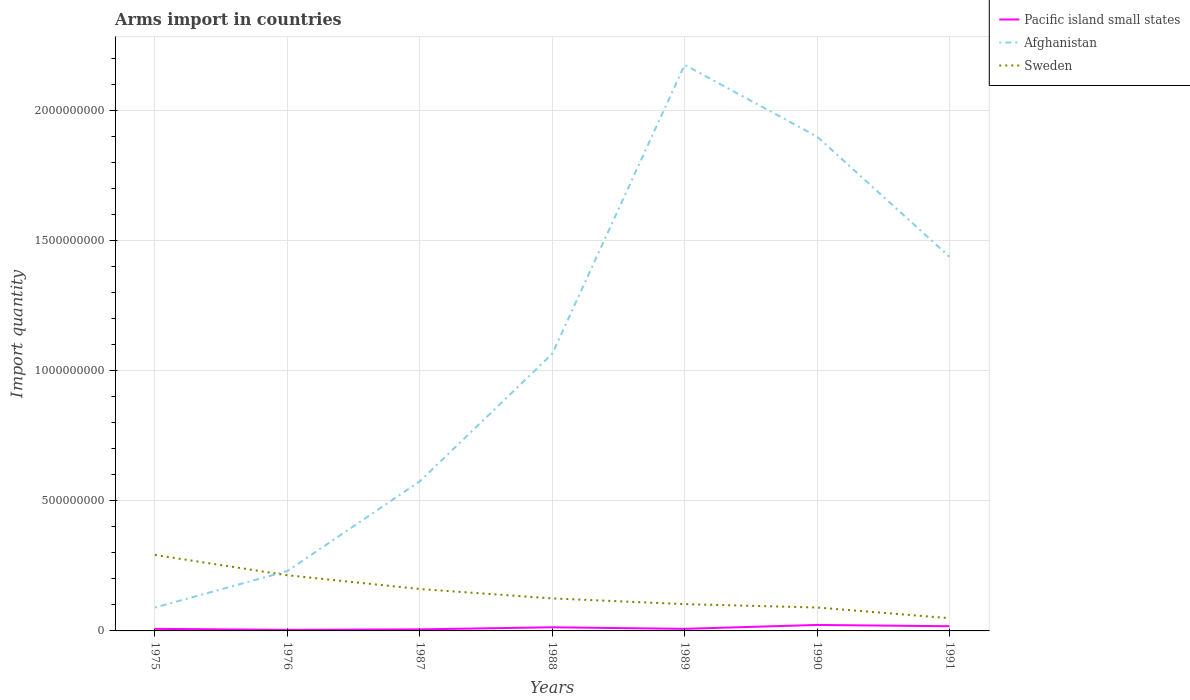Across all years, what is the maximum total arms import in Pacific island small states?
Provide a short and direct response. 4.00e+06. In which year was the total arms import in Pacific island small states maximum?
Offer a terse response. 1976. What is the total total arms import in Sweden in the graph?
Keep it short and to the point. 7.10e+07. What is the difference between the highest and the second highest total arms import in Afghanistan?
Make the answer very short. 2.09e+09. What is the difference between the highest and the lowest total arms import in Afghanistan?
Your answer should be compact. 3. Is the total arms import in Sweden strictly greater than the total arms import in Pacific island small states over the years?
Make the answer very short. No. How many lines are there?
Give a very brief answer. 3. How many years are there in the graph?
Keep it short and to the point. 7. Where does the legend appear in the graph?
Keep it short and to the point. Top right. How many legend labels are there?
Offer a terse response. 3. How are the legend labels stacked?
Give a very brief answer. Vertical. What is the title of the graph?
Your response must be concise. Arms import in countries. What is the label or title of the Y-axis?
Offer a terse response. Import quantity. What is the Import quantity of Pacific island small states in 1975?
Your answer should be very brief. 8.00e+06. What is the Import quantity of Afghanistan in 1975?
Give a very brief answer. 9.00e+07. What is the Import quantity of Sweden in 1975?
Your response must be concise. 2.92e+08. What is the Import quantity of Afghanistan in 1976?
Provide a short and direct response. 2.30e+08. What is the Import quantity of Sweden in 1976?
Keep it short and to the point. 2.14e+08. What is the Import quantity of Afghanistan in 1987?
Your answer should be very brief. 5.75e+08. What is the Import quantity in Sweden in 1987?
Your response must be concise. 1.61e+08. What is the Import quantity in Pacific island small states in 1988?
Offer a very short reply. 1.40e+07. What is the Import quantity in Afghanistan in 1988?
Your answer should be compact. 1.06e+09. What is the Import quantity of Sweden in 1988?
Provide a succinct answer. 1.25e+08. What is the Import quantity of Pacific island small states in 1989?
Keep it short and to the point. 8.00e+06. What is the Import quantity in Afghanistan in 1989?
Provide a short and direct response. 2.18e+09. What is the Import quantity of Sweden in 1989?
Provide a short and direct response. 1.03e+08. What is the Import quantity in Pacific island small states in 1990?
Make the answer very short. 2.30e+07. What is the Import quantity of Afghanistan in 1990?
Provide a short and direct response. 1.90e+09. What is the Import quantity in Sweden in 1990?
Keep it short and to the point. 9.00e+07. What is the Import quantity of Pacific island small states in 1991?
Keep it short and to the point. 1.80e+07. What is the Import quantity in Afghanistan in 1991?
Your answer should be very brief. 1.44e+09. What is the Import quantity in Sweden in 1991?
Offer a very short reply. 4.90e+07. Across all years, what is the maximum Import quantity in Pacific island small states?
Keep it short and to the point. 2.30e+07. Across all years, what is the maximum Import quantity of Afghanistan?
Your answer should be compact. 2.18e+09. Across all years, what is the maximum Import quantity of Sweden?
Offer a terse response. 2.92e+08. Across all years, what is the minimum Import quantity of Pacific island small states?
Provide a succinct answer. 4.00e+06. Across all years, what is the minimum Import quantity in Afghanistan?
Provide a succinct answer. 9.00e+07. Across all years, what is the minimum Import quantity of Sweden?
Your answer should be very brief. 4.90e+07. What is the total Import quantity of Pacific island small states in the graph?
Your response must be concise. 8.10e+07. What is the total Import quantity in Afghanistan in the graph?
Provide a short and direct response. 7.47e+09. What is the total Import quantity in Sweden in the graph?
Your answer should be compact. 1.03e+09. What is the difference between the Import quantity of Pacific island small states in 1975 and that in 1976?
Your answer should be very brief. 4.00e+06. What is the difference between the Import quantity in Afghanistan in 1975 and that in 1976?
Your answer should be very brief. -1.40e+08. What is the difference between the Import quantity of Sweden in 1975 and that in 1976?
Ensure brevity in your answer.  7.80e+07. What is the difference between the Import quantity of Pacific island small states in 1975 and that in 1987?
Your response must be concise. 2.00e+06. What is the difference between the Import quantity of Afghanistan in 1975 and that in 1987?
Your answer should be very brief. -4.85e+08. What is the difference between the Import quantity of Sweden in 1975 and that in 1987?
Provide a short and direct response. 1.31e+08. What is the difference between the Import quantity of Pacific island small states in 1975 and that in 1988?
Your answer should be compact. -6.00e+06. What is the difference between the Import quantity in Afghanistan in 1975 and that in 1988?
Your response must be concise. -9.75e+08. What is the difference between the Import quantity in Sweden in 1975 and that in 1988?
Ensure brevity in your answer.  1.67e+08. What is the difference between the Import quantity in Afghanistan in 1975 and that in 1989?
Offer a very short reply. -2.09e+09. What is the difference between the Import quantity of Sweden in 1975 and that in 1989?
Make the answer very short. 1.89e+08. What is the difference between the Import quantity in Pacific island small states in 1975 and that in 1990?
Keep it short and to the point. -1.50e+07. What is the difference between the Import quantity of Afghanistan in 1975 and that in 1990?
Offer a terse response. -1.81e+09. What is the difference between the Import quantity of Sweden in 1975 and that in 1990?
Your answer should be compact. 2.02e+08. What is the difference between the Import quantity in Pacific island small states in 1975 and that in 1991?
Your response must be concise. -1.00e+07. What is the difference between the Import quantity in Afghanistan in 1975 and that in 1991?
Keep it short and to the point. -1.35e+09. What is the difference between the Import quantity in Sweden in 1975 and that in 1991?
Your answer should be very brief. 2.43e+08. What is the difference between the Import quantity of Afghanistan in 1976 and that in 1987?
Your response must be concise. -3.45e+08. What is the difference between the Import quantity of Sweden in 1976 and that in 1987?
Your answer should be compact. 5.30e+07. What is the difference between the Import quantity of Pacific island small states in 1976 and that in 1988?
Make the answer very short. -1.00e+07. What is the difference between the Import quantity in Afghanistan in 1976 and that in 1988?
Provide a short and direct response. -8.35e+08. What is the difference between the Import quantity in Sweden in 1976 and that in 1988?
Provide a succinct answer. 8.90e+07. What is the difference between the Import quantity in Pacific island small states in 1976 and that in 1989?
Offer a very short reply. -4.00e+06. What is the difference between the Import quantity in Afghanistan in 1976 and that in 1989?
Ensure brevity in your answer.  -1.95e+09. What is the difference between the Import quantity of Sweden in 1976 and that in 1989?
Provide a short and direct response. 1.11e+08. What is the difference between the Import quantity of Pacific island small states in 1976 and that in 1990?
Provide a succinct answer. -1.90e+07. What is the difference between the Import quantity of Afghanistan in 1976 and that in 1990?
Make the answer very short. -1.67e+09. What is the difference between the Import quantity in Sweden in 1976 and that in 1990?
Provide a succinct answer. 1.24e+08. What is the difference between the Import quantity of Pacific island small states in 1976 and that in 1991?
Offer a terse response. -1.40e+07. What is the difference between the Import quantity in Afghanistan in 1976 and that in 1991?
Offer a very short reply. -1.21e+09. What is the difference between the Import quantity in Sweden in 1976 and that in 1991?
Your answer should be very brief. 1.65e+08. What is the difference between the Import quantity in Pacific island small states in 1987 and that in 1988?
Make the answer very short. -8.00e+06. What is the difference between the Import quantity in Afghanistan in 1987 and that in 1988?
Provide a succinct answer. -4.90e+08. What is the difference between the Import quantity of Sweden in 1987 and that in 1988?
Ensure brevity in your answer.  3.60e+07. What is the difference between the Import quantity of Afghanistan in 1987 and that in 1989?
Provide a succinct answer. -1.60e+09. What is the difference between the Import quantity of Sweden in 1987 and that in 1989?
Your response must be concise. 5.80e+07. What is the difference between the Import quantity in Pacific island small states in 1987 and that in 1990?
Your answer should be compact. -1.70e+07. What is the difference between the Import quantity of Afghanistan in 1987 and that in 1990?
Give a very brief answer. -1.32e+09. What is the difference between the Import quantity in Sweden in 1987 and that in 1990?
Your response must be concise. 7.10e+07. What is the difference between the Import quantity in Pacific island small states in 1987 and that in 1991?
Give a very brief answer. -1.20e+07. What is the difference between the Import quantity in Afghanistan in 1987 and that in 1991?
Provide a succinct answer. -8.63e+08. What is the difference between the Import quantity in Sweden in 1987 and that in 1991?
Your answer should be compact. 1.12e+08. What is the difference between the Import quantity in Afghanistan in 1988 and that in 1989?
Give a very brief answer. -1.11e+09. What is the difference between the Import quantity of Sweden in 1988 and that in 1989?
Provide a succinct answer. 2.20e+07. What is the difference between the Import quantity of Pacific island small states in 1988 and that in 1990?
Offer a terse response. -9.00e+06. What is the difference between the Import quantity in Afghanistan in 1988 and that in 1990?
Provide a short and direct response. -8.35e+08. What is the difference between the Import quantity of Sweden in 1988 and that in 1990?
Your response must be concise. 3.50e+07. What is the difference between the Import quantity in Pacific island small states in 1988 and that in 1991?
Keep it short and to the point. -4.00e+06. What is the difference between the Import quantity of Afghanistan in 1988 and that in 1991?
Ensure brevity in your answer.  -3.73e+08. What is the difference between the Import quantity in Sweden in 1988 and that in 1991?
Keep it short and to the point. 7.60e+07. What is the difference between the Import quantity of Pacific island small states in 1989 and that in 1990?
Your answer should be compact. -1.50e+07. What is the difference between the Import quantity in Afghanistan in 1989 and that in 1990?
Give a very brief answer. 2.76e+08. What is the difference between the Import quantity of Sweden in 1989 and that in 1990?
Your response must be concise. 1.30e+07. What is the difference between the Import quantity of Pacific island small states in 1989 and that in 1991?
Offer a terse response. -1.00e+07. What is the difference between the Import quantity in Afghanistan in 1989 and that in 1991?
Make the answer very short. 7.38e+08. What is the difference between the Import quantity in Sweden in 1989 and that in 1991?
Your response must be concise. 5.40e+07. What is the difference between the Import quantity in Pacific island small states in 1990 and that in 1991?
Give a very brief answer. 5.00e+06. What is the difference between the Import quantity in Afghanistan in 1990 and that in 1991?
Keep it short and to the point. 4.62e+08. What is the difference between the Import quantity in Sweden in 1990 and that in 1991?
Your answer should be very brief. 4.10e+07. What is the difference between the Import quantity in Pacific island small states in 1975 and the Import quantity in Afghanistan in 1976?
Your answer should be very brief. -2.22e+08. What is the difference between the Import quantity in Pacific island small states in 1975 and the Import quantity in Sweden in 1976?
Keep it short and to the point. -2.06e+08. What is the difference between the Import quantity in Afghanistan in 1975 and the Import quantity in Sweden in 1976?
Your answer should be compact. -1.24e+08. What is the difference between the Import quantity of Pacific island small states in 1975 and the Import quantity of Afghanistan in 1987?
Your answer should be compact. -5.67e+08. What is the difference between the Import quantity in Pacific island small states in 1975 and the Import quantity in Sweden in 1987?
Your answer should be compact. -1.53e+08. What is the difference between the Import quantity of Afghanistan in 1975 and the Import quantity of Sweden in 1987?
Your response must be concise. -7.10e+07. What is the difference between the Import quantity in Pacific island small states in 1975 and the Import quantity in Afghanistan in 1988?
Your answer should be compact. -1.06e+09. What is the difference between the Import quantity in Pacific island small states in 1975 and the Import quantity in Sweden in 1988?
Your answer should be compact. -1.17e+08. What is the difference between the Import quantity in Afghanistan in 1975 and the Import quantity in Sweden in 1988?
Offer a terse response. -3.50e+07. What is the difference between the Import quantity in Pacific island small states in 1975 and the Import quantity in Afghanistan in 1989?
Your answer should be very brief. -2.17e+09. What is the difference between the Import quantity in Pacific island small states in 1975 and the Import quantity in Sweden in 1989?
Provide a short and direct response. -9.50e+07. What is the difference between the Import quantity in Afghanistan in 1975 and the Import quantity in Sweden in 1989?
Provide a short and direct response. -1.30e+07. What is the difference between the Import quantity in Pacific island small states in 1975 and the Import quantity in Afghanistan in 1990?
Provide a succinct answer. -1.89e+09. What is the difference between the Import quantity in Pacific island small states in 1975 and the Import quantity in Sweden in 1990?
Offer a very short reply. -8.20e+07. What is the difference between the Import quantity in Afghanistan in 1975 and the Import quantity in Sweden in 1990?
Your answer should be compact. 0. What is the difference between the Import quantity in Pacific island small states in 1975 and the Import quantity in Afghanistan in 1991?
Keep it short and to the point. -1.43e+09. What is the difference between the Import quantity in Pacific island small states in 1975 and the Import quantity in Sweden in 1991?
Your answer should be very brief. -4.10e+07. What is the difference between the Import quantity in Afghanistan in 1975 and the Import quantity in Sweden in 1991?
Your response must be concise. 4.10e+07. What is the difference between the Import quantity in Pacific island small states in 1976 and the Import quantity in Afghanistan in 1987?
Ensure brevity in your answer.  -5.71e+08. What is the difference between the Import quantity of Pacific island small states in 1976 and the Import quantity of Sweden in 1987?
Provide a succinct answer. -1.57e+08. What is the difference between the Import quantity in Afghanistan in 1976 and the Import quantity in Sweden in 1987?
Provide a short and direct response. 6.90e+07. What is the difference between the Import quantity of Pacific island small states in 1976 and the Import quantity of Afghanistan in 1988?
Offer a very short reply. -1.06e+09. What is the difference between the Import quantity in Pacific island small states in 1976 and the Import quantity in Sweden in 1988?
Your answer should be very brief. -1.21e+08. What is the difference between the Import quantity in Afghanistan in 1976 and the Import quantity in Sweden in 1988?
Make the answer very short. 1.05e+08. What is the difference between the Import quantity in Pacific island small states in 1976 and the Import quantity in Afghanistan in 1989?
Offer a terse response. -2.17e+09. What is the difference between the Import quantity in Pacific island small states in 1976 and the Import quantity in Sweden in 1989?
Provide a short and direct response. -9.90e+07. What is the difference between the Import quantity in Afghanistan in 1976 and the Import quantity in Sweden in 1989?
Provide a short and direct response. 1.27e+08. What is the difference between the Import quantity in Pacific island small states in 1976 and the Import quantity in Afghanistan in 1990?
Provide a short and direct response. -1.90e+09. What is the difference between the Import quantity in Pacific island small states in 1976 and the Import quantity in Sweden in 1990?
Keep it short and to the point. -8.60e+07. What is the difference between the Import quantity in Afghanistan in 1976 and the Import quantity in Sweden in 1990?
Offer a very short reply. 1.40e+08. What is the difference between the Import quantity in Pacific island small states in 1976 and the Import quantity in Afghanistan in 1991?
Provide a succinct answer. -1.43e+09. What is the difference between the Import quantity of Pacific island small states in 1976 and the Import quantity of Sweden in 1991?
Keep it short and to the point. -4.50e+07. What is the difference between the Import quantity of Afghanistan in 1976 and the Import quantity of Sweden in 1991?
Ensure brevity in your answer.  1.81e+08. What is the difference between the Import quantity in Pacific island small states in 1987 and the Import quantity in Afghanistan in 1988?
Your response must be concise. -1.06e+09. What is the difference between the Import quantity of Pacific island small states in 1987 and the Import quantity of Sweden in 1988?
Ensure brevity in your answer.  -1.19e+08. What is the difference between the Import quantity of Afghanistan in 1987 and the Import quantity of Sweden in 1988?
Provide a succinct answer. 4.50e+08. What is the difference between the Import quantity in Pacific island small states in 1987 and the Import quantity in Afghanistan in 1989?
Give a very brief answer. -2.17e+09. What is the difference between the Import quantity of Pacific island small states in 1987 and the Import quantity of Sweden in 1989?
Give a very brief answer. -9.70e+07. What is the difference between the Import quantity of Afghanistan in 1987 and the Import quantity of Sweden in 1989?
Offer a very short reply. 4.72e+08. What is the difference between the Import quantity of Pacific island small states in 1987 and the Import quantity of Afghanistan in 1990?
Your response must be concise. -1.89e+09. What is the difference between the Import quantity of Pacific island small states in 1987 and the Import quantity of Sweden in 1990?
Your answer should be very brief. -8.40e+07. What is the difference between the Import quantity of Afghanistan in 1987 and the Import quantity of Sweden in 1990?
Provide a succinct answer. 4.85e+08. What is the difference between the Import quantity of Pacific island small states in 1987 and the Import quantity of Afghanistan in 1991?
Offer a very short reply. -1.43e+09. What is the difference between the Import quantity of Pacific island small states in 1987 and the Import quantity of Sweden in 1991?
Provide a short and direct response. -4.30e+07. What is the difference between the Import quantity of Afghanistan in 1987 and the Import quantity of Sweden in 1991?
Offer a very short reply. 5.26e+08. What is the difference between the Import quantity in Pacific island small states in 1988 and the Import quantity in Afghanistan in 1989?
Your answer should be compact. -2.16e+09. What is the difference between the Import quantity of Pacific island small states in 1988 and the Import quantity of Sweden in 1989?
Offer a terse response. -8.90e+07. What is the difference between the Import quantity in Afghanistan in 1988 and the Import quantity in Sweden in 1989?
Offer a terse response. 9.62e+08. What is the difference between the Import quantity of Pacific island small states in 1988 and the Import quantity of Afghanistan in 1990?
Your response must be concise. -1.89e+09. What is the difference between the Import quantity of Pacific island small states in 1988 and the Import quantity of Sweden in 1990?
Provide a short and direct response. -7.60e+07. What is the difference between the Import quantity of Afghanistan in 1988 and the Import quantity of Sweden in 1990?
Keep it short and to the point. 9.75e+08. What is the difference between the Import quantity of Pacific island small states in 1988 and the Import quantity of Afghanistan in 1991?
Ensure brevity in your answer.  -1.42e+09. What is the difference between the Import quantity of Pacific island small states in 1988 and the Import quantity of Sweden in 1991?
Give a very brief answer. -3.50e+07. What is the difference between the Import quantity of Afghanistan in 1988 and the Import quantity of Sweden in 1991?
Keep it short and to the point. 1.02e+09. What is the difference between the Import quantity in Pacific island small states in 1989 and the Import quantity in Afghanistan in 1990?
Provide a succinct answer. -1.89e+09. What is the difference between the Import quantity in Pacific island small states in 1989 and the Import quantity in Sweden in 1990?
Ensure brevity in your answer.  -8.20e+07. What is the difference between the Import quantity of Afghanistan in 1989 and the Import quantity of Sweden in 1990?
Offer a terse response. 2.09e+09. What is the difference between the Import quantity in Pacific island small states in 1989 and the Import quantity in Afghanistan in 1991?
Your answer should be compact. -1.43e+09. What is the difference between the Import quantity in Pacific island small states in 1989 and the Import quantity in Sweden in 1991?
Your answer should be very brief. -4.10e+07. What is the difference between the Import quantity in Afghanistan in 1989 and the Import quantity in Sweden in 1991?
Offer a very short reply. 2.13e+09. What is the difference between the Import quantity in Pacific island small states in 1990 and the Import quantity in Afghanistan in 1991?
Give a very brief answer. -1.42e+09. What is the difference between the Import quantity in Pacific island small states in 1990 and the Import quantity in Sweden in 1991?
Provide a succinct answer. -2.60e+07. What is the difference between the Import quantity of Afghanistan in 1990 and the Import quantity of Sweden in 1991?
Your answer should be compact. 1.85e+09. What is the average Import quantity in Pacific island small states per year?
Offer a very short reply. 1.16e+07. What is the average Import quantity in Afghanistan per year?
Provide a succinct answer. 1.07e+09. What is the average Import quantity of Sweden per year?
Give a very brief answer. 1.48e+08. In the year 1975, what is the difference between the Import quantity in Pacific island small states and Import quantity in Afghanistan?
Provide a short and direct response. -8.20e+07. In the year 1975, what is the difference between the Import quantity of Pacific island small states and Import quantity of Sweden?
Provide a short and direct response. -2.84e+08. In the year 1975, what is the difference between the Import quantity of Afghanistan and Import quantity of Sweden?
Offer a terse response. -2.02e+08. In the year 1976, what is the difference between the Import quantity in Pacific island small states and Import quantity in Afghanistan?
Your answer should be compact. -2.26e+08. In the year 1976, what is the difference between the Import quantity of Pacific island small states and Import quantity of Sweden?
Provide a short and direct response. -2.10e+08. In the year 1976, what is the difference between the Import quantity in Afghanistan and Import quantity in Sweden?
Your answer should be very brief. 1.60e+07. In the year 1987, what is the difference between the Import quantity in Pacific island small states and Import quantity in Afghanistan?
Your answer should be compact. -5.69e+08. In the year 1987, what is the difference between the Import quantity of Pacific island small states and Import quantity of Sweden?
Offer a terse response. -1.55e+08. In the year 1987, what is the difference between the Import quantity of Afghanistan and Import quantity of Sweden?
Provide a succinct answer. 4.14e+08. In the year 1988, what is the difference between the Import quantity of Pacific island small states and Import quantity of Afghanistan?
Offer a terse response. -1.05e+09. In the year 1988, what is the difference between the Import quantity of Pacific island small states and Import quantity of Sweden?
Your answer should be very brief. -1.11e+08. In the year 1988, what is the difference between the Import quantity of Afghanistan and Import quantity of Sweden?
Make the answer very short. 9.40e+08. In the year 1989, what is the difference between the Import quantity of Pacific island small states and Import quantity of Afghanistan?
Provide a short and direct response. -2.17e+09. In the year 1989, what is the difference between the Import quantity in Pacific island small states and Import quantity in Sweden?
Your answer should be compact. -9.50e+07. In the year 1989, what is the difference between the Import quantity in Afghanistan and Import quantity in Sweden?
Your answer should be very brief. 2.07e+09. In the year 1990, what is the difference between the Import quantity in Pacific island small states and Import quantity in Afghanistan?
Offer a very short reply. -1.88e+09. In the year 1990, what is the difference between the Import quantity of Pacific island small states and Import quantity of Sweden?
Make the answer very short. -6.70e+07. In the year 1990, what is the difference between the Import quantity in Afghanistan and Import quantity in Sweden?
Keep it short and to the point. 1.81e+09. In the year 1991, what is the difference between the Import quantity of Pacific island small states and Import quantity of Afghanistan?
Your answer should be very brief. -1.42e+09. In the year 1991, what is the difference between the Import quantity in Pacific island small states and Import quantity in Sweden?
Ensure brevity in your answer.  -3.10e+07. In the year 1991, what is the difference between the Import quantity in Afghanistan and Import quantity in Sweden?
Provide a short and direct response. 1.39e+09. What is the ratio of the Import quantity of Pacific island small states in 1975 to that in 1976?
Provide a short and direct response. 2. What is the ratio of the Import quantity in Afghanistan in 1975 to that in 1976?
Keep it short and to the point. 0.39. What is the ratio of the Import quantity in Sweden in 1975 to that in 1976?
Your response must be concise. 1.36. What is the ratio of the Import quantity of Afghanistan in 1975 to that in 1987?
Keep it short and to the point. 0.16. What is the ratio of the Import quantity of Sweden in 1975 to that in 1987?
Your answer should be very brief. 1.81. What is the ratio of the Import quantity of Afghanistan in 1975 to that in 1988?
Keep it short and to the point. 0.08. What is the ratio of the Import quantity in Sweden in 1975 to that in 1988?
Make the answer very short. 2.34. What is the ratio of the Import quantity of Afghanistan in 1975 to that in 1989?
Offer a terse response. 0.04. What is the ratio of the Import quantity of Sweden in 1975 to that in 1989?
Your answer should be compact. 2.83. What is the ratio of the Import quantity in Pacific island small states in 1975 to that in 1990?
Make the answer very short. 0.35. What is the ratio of the Import quantity in Afghanistan in 1975 to that in 1990?
Make the answer very short. 0.05. What is the ratio of the Import quantity in Sweden in 1975 to that in 1990?
Your response must be concise. 3.24. What is the ratio of the Import quantity of Pacific island small states in 1975 to that in 1991?
Your answer should be compact. 0.44. What is the ratio of the Import quantity in Afghanistan in 1975 to that in 1991?
Provide a succinct answer. 0.06. What is the ratio of the Import quantity in Sweden in 1975 to that in 1991?
Provide a succinct answer. 5.96. What is the ratio of the Import quantity of Pacific island small states in 1976 to that in 1987?
Your answer should be very brief. 0.67. What is the ratio of the Import quantity of Afghanistan in 1976 to that in 1987?
Your answer should be compact. 0.4. What is the ratio of the Import quantity of Sweden in 1976 to that in 1987?
Make the answer very short. 1.33. What is the ratio of the Import quantity in Pacific island small states in 1976 to that in 1988?
Give a very brief answer. 0.29. What is the ratio of the Import quantity in Afghanistan in 1976 to that in 1988?
Ensure brevity in your answer.  0.22. What is the ratio of the Import quantity in Sweden in 1976 to that in 1988?
Provide a succinct answer. 1.71. What is the ratio of the Import quantity in Afghanistan in 1976 to that in 1989?
Your response must be concise. 0.11. What is the ratio of the Import quantity in Sweden in 1976 to that in 1989?
Give a very brief answer. 2.08. What is the ratio of the Import quantity in Pacific island small states in 1976 to that in 1990?
Your answer should be very brief. 0.17. What is the ratio of the Import quantity of Afghanistan in 1976 to that in 1990?
Offer a very short reply. 0.12. What is the ratio of the Import quantity in Sweden in 1976 to that in 1990?
Provide a short and direct response. 2.38. What is the ratio of the Import quantity of Pacific island small states in 1976 to that in 1991?
Your response must be concise. 0.22. What is the ratio of the Import quantity of Afghanistan in 1976 to that in 1991?
Provide a short and direct response. 0.16. What is the ratio of the Import quantity of Sweden in 1976 to that in 1991?
Your answer should be compact. 4.37. What is the ratio of the Import quantity in Pacific island small states in 1987 to that in 1988?
Your response must be concise. 0.43. What is the ratio of the Import quantity of Afghanistan in 1987 to that in 1988?
Your answer should be very brief. 0.54. What is the ratio of the Import quantity of Sweden in 1987 to that in 1988?
Offer a terse response. 1.29. What is the ratio of the Import quantity of Pacific island small states in 1987 to that in 1989?
Ensure brevity in your answer.  0.75. What is the ratio of the Import quantity of Afghanistan in 1987 to that in 1989?
Ensure brevity in your answer.  0.26. What is the ratio of the Import quantity of Sweden in 1987 to that in 1989?
Offer a terse response. 1.56. What is the ratio of the Import quantity of Pacific island small states in 1987 to that in 1990?
Keep it short and to the point. 0.26. What is the ratio of the Import quantity of Afghanistan in 1987 to that in 1990?
Keep it short and to the point. 0.3. What is the ratio of the Import quantity of Sweden in 1987 to that in 1990?
Keep it short and to the point. 1.79. What is the ratio of the Import quantity of Pacific island small states in 1987 to that in 1991?
Your response must be concise. 0.33. What is the ratio of the Import quantity of Afghanistan in 1987 to that in 1991?
Ensure brevity in your answer.  0.4. What is the ratio of the Import quantity of Sweden in 1987 to that in 1991?
Give a very brief answer. 3.29. What is the ratio of the Import quantity of Pacific island small states in 1988 to that in 1989?
Offer a very short reply. 1.75. What is the ratio of the Import quantity of Afghanistan in 1988 to that in 1989?
Your response must be concise. 0.49. What is the ratio of the Import quantity in Sweden in 1988 to that in 1989?
Provide a succinct answer. 1.21. What is the ratio of the Import quantity of Pacific island small states in 1988 to that in 1990?
Keep it short and to the point. 0.61. What is the ratio of the Import quantity in Afghanistan in 1988 to that in 1990?
Your response must be concise. 0.56. What is the ratio of the Import quantity of Sweden in 1988 to that in 1990?
Your answer should be very brief. 1.39. What is the ratio of the Import quantity in Pacific island small states in 1988 to that in 1991?
Your answer should be compact. 0.78. What is the ratio of the Import quantity of Afghanistan in 1988 to that in 1991?
Your response must be concise. 0.74. What is the ratio of the Import quantity of Sweden in 1988 to that in 1991?
Ensure brevity in your answer.  2.55. What is the ratio of the Import quantity in Pacific island small states in 1989 to that in 1990?
Offer a very short reply. 0.35. What is the ratio of the Import quantity in Afghanistan in 1989 to that in 1990?
Give a very brief answer. 1.15. What is the ratio of the Import quantity in Sweden in 1989 to that in 1990?
Your response must be concise. 1.14. What is the ratio of the Import quantity in Pacific island small states in 1989 to that in 1991?
Your response must be concise. 0.44. What is the ratio of the Import quantity in Afghanistan in 1989 to that in 1991?
Your response must be concise. 1.51. What is the ratio of the Import quantity in Sweden in 1989 to that in 1991?
Keep it short and to the point. 2.1. What is the ratio of the Import quantity of Pacific island small states in 1990 to that in 1991?
Provide a succinct answer. 1.28. What is the ratio of the Import quantity in Afghanistan in 1990 to that in 1991?
Your answer should be compact. 1.32. What is the ratio of the Import quantity in Sweden in 1990 to that in 1991?
Your answer should be very brief. 1.84. What is the difference between the highest and the second highest Import quantity of Afghanistan?
Your response must be concise. 2.76e+08. What is the difference between the highest and the second highest Import quantity in Sweden?
Your response must be concise. 7.80e+07. What is the difference between the highest and the lowest Import quantity of Pacific island small states?
Give a very brief answer. 1.90e+07. What is the difference between the highest and the lowest Import quantity of Afghanistan?
Make the answer very short. 2.09e+09. What is the difference between the highest and the lowest Import quantity in Sweden?
Your response must be concise. 2.43e+08. 